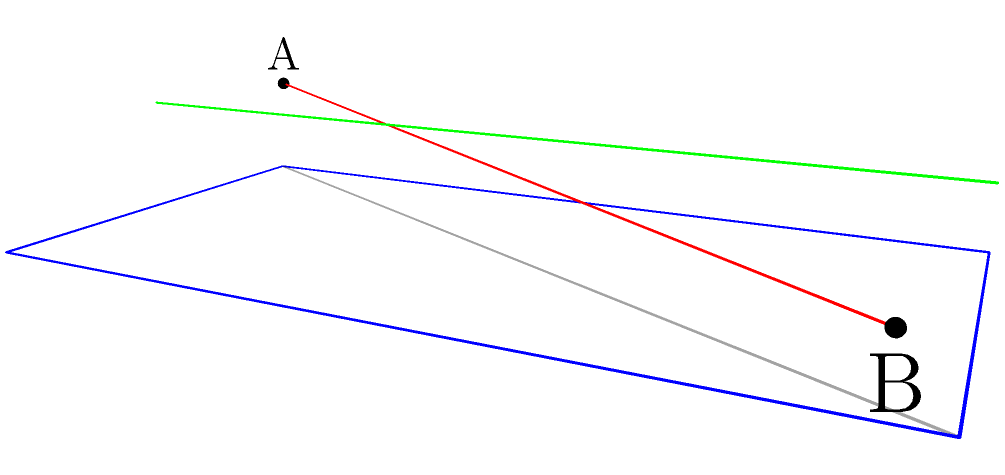In a crucial volleyball match, you're analyzing the serve trajectory to optimize your technique and minimize injury risk. The serve originates from point A (1,1,2.5) and lands at point B (8,17,1) on the opponent's court. What is the angle $\theta$ between the plane containing the serve trajectory and the horizontal ground plane? To find the angle between the two planes, we'll follow these steps:

1) First, we need to find the normal vectors of both planes:

   a) For the serve trajectory plane:
      - Direction vector of AB: $\vec{v} = (7, 16, -1.5)$
      - A point on the plane: A(1,1,2.5)
      - Normal vector $\vec{n_1} = (1,1,2.5) \times (7,16,-1.5) = (-41.5, 12.25, -9)$

   b) For the ground plane:
      - Normal vector $\vec{n_2} = (0, 0, 1)$

2) The angle between two planes is the same as the angle between their normal vectors. We can find this using the dot product formula:

   $$\cos \theta = \frac{\vec{n_1} \cdot \vec{n_2}}{|\vec{n_1}||\vec{n_2}|}$$

3) Calculate the dot product:
   $\vec{n_1} \cdot \vec{n_2} = (-41.5 \times 0) + (12.25 \times 0) + (-9 \times 1) = -9$

4) Calculate the magnitudes:
   $|\vec{n_1}| = \sqrt{(-41.5)^2 + 12.25^2 + (-9)^2} = \sqrt{1720.5625 + 150.0625 + 81} = \sqrt{1951.625} \approx 44.18$
   $|\vec{n_2}| = 1$

5) Substitute into the formula:
   $$\cos \theta = \frac{-9}{44.18 \times 1} \approx -0.2037$$

6) Take the inverse cosine (arccos) of both sides:
   $$\theta = \arccos(-0.2037) \approx 1.7744 \text{ radians}$$

7) Convert to degrees:
   $$\theta \approx 1.7744 \times \frac{180}{\pi} \approx 101.68°$$
Answer: $101.68°$ 